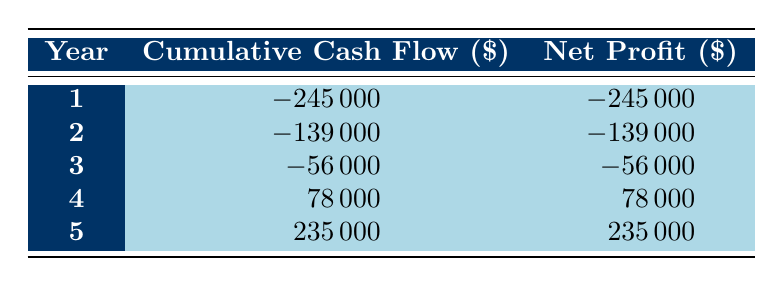What is the cumulative cash flow in year 4? The table shows the cumulative cash flow for each year. For year 4, the cumulative cash flow is listed directly as 78000.
Answer: 78000 What is the net profit in year 5? According to the table, the net profit for year 5 is directly given as 235000.
Answer: 235000 What was the total cumulative cash flow over the five years? To find the total cumulative cash flow, we look at the final year (year 5), where the cumulative cash flow is 235000. This is the total since it includes all previous years.
Answer: 235000 Is the net profit always negative in the first three years? By looking at the table, we can see the net profit for years 1, 2, and 3 are -245000, -139000, and -56000 respectively, confirming that all these values are negative.
Answer: Yes What was the total increase in cumulative cash flow from year 3 to year 5? For cumulative cash flow in year 3, it is -56000, and in year 5, it is 235000. To find the increase, we subtract the amount in year 3 from that in year 5: 235000 - (-56000) = 235000 + 56000 = 291000.
Answer: 291000 What is the cumulative cash flow in year 2 minus the cumulative cash flow in year 1? From the table, the cumulative cash flow for year 2 is -139000 and for year 1 is -245000. The difference is -139000 - (-245000) = -139000 + 245000 = 106000.
Answer: 106000 In which year does the net profit first become positive? The table shows that the net profit becomes positive in year 4, where it is 78000. In years 1, 2, and 3, the net profit values are all negative.
Answer: Year 4 What is the average annual net profit over the 5 years? Net profits over the 5 years are -245000, -139000, -56000, 78000, and 235000. We sum these values: (-245000 - 139000 - 56000 + 78000 + 235000) = -245000 + 78000 + 235000 - 139000 - 56000 = -200000. Therefore, the average annual net profit is -200000/5 = -40000.
Answer: -40000 